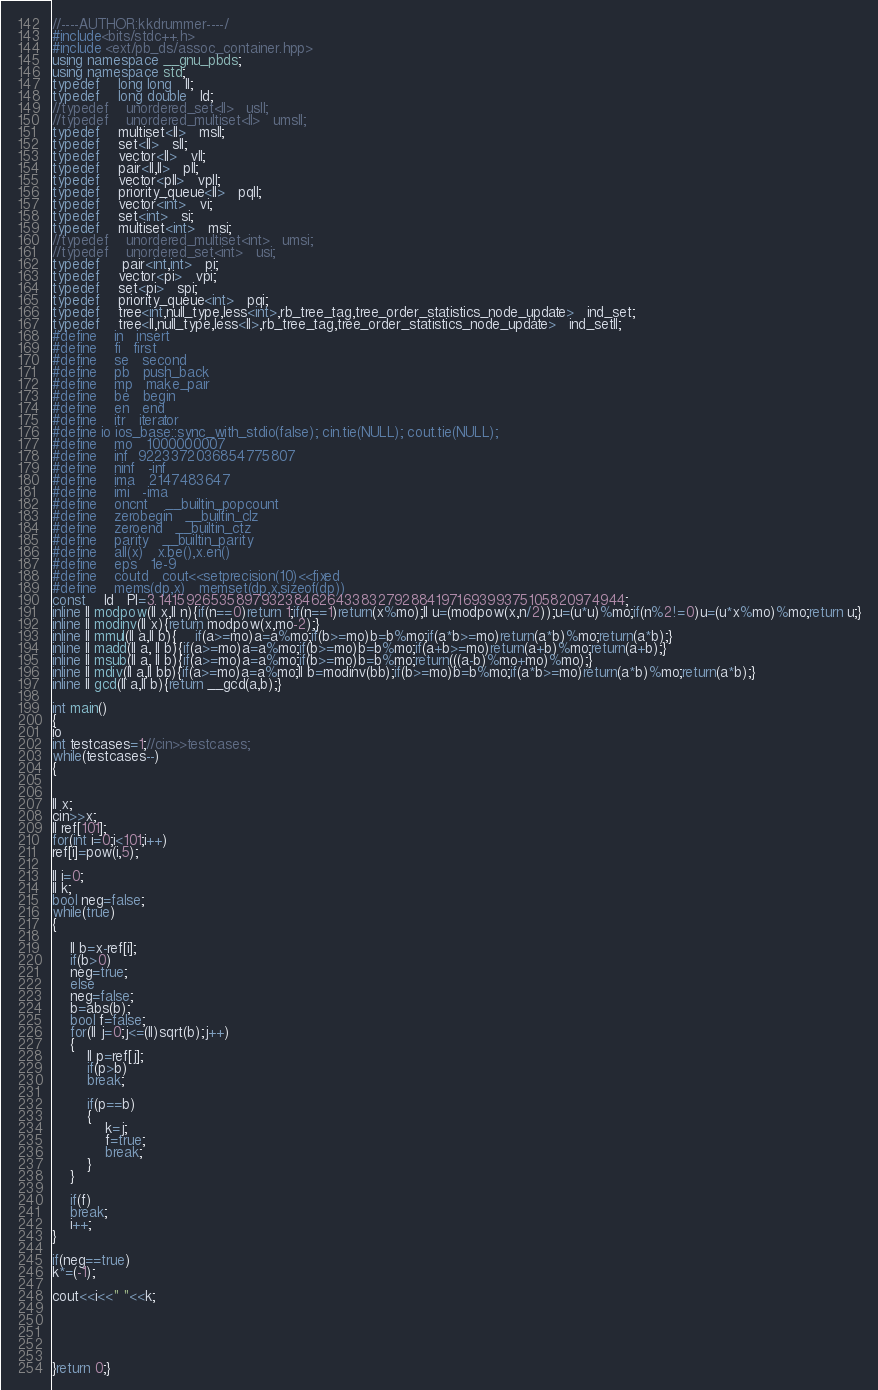Convert code to text. <code><loc_0><loc_0><loc_500><loc_500><_C++_>//----AUTHOR:kkdrummer----/
#include<bits/stdc++.h>
#include <ext/pb_ds/assoc_container.hpp>
using namespace __gnu_pbds;
using namespace std;
typedef    long long   ll;
typedef    long double   ld;
//typedef    unordered_set<ll>   usll;
//typedef    unordered_multiset<ll>   umsll;
typedef    multiset<ll>   msll;
typedef    set<ll>   sll;
typedef    vector<ll>   vll;
typedef    pair<ll,ll>   pll;
typedef    vector<pll>   vpll;
typedef    priority_queue<ll>   pqll;
typedef    vector<int>   vi;
typedef    set<int>   si;
typedef    multiset<int>   msi;
//typedef    unordered_multiset<int>   umsi;
//typedef    unordered_set<int>   usi;
typedef     pair<int,int>   pi;
typedef    vector<pi>   vpi;
typedef    set<pi>   spi;
typedef    priority_queue<int>   pqi;
typedef    tree<int,null_type,less<int>,rb_tree_tag,tree_order_statistics_node_update>   ind_set;
typedef    tree<ll,null_type,less<ll>,rb_tree_tag,tree_order_statistics_node_update>   ind_setll;
#define    in   insert
#define    fi   first
#define    se   second
#define    pb   push_back
#define    mp   make_pair
#define    be   begin
#define    en   end
#define    itr   iterator
#define io ios_base::sync_with_stdio(false); cin.tie(NULL); cout.tie(NULL);
#define    mo   1000000007
#define    inf  9223372036854775807
#define    ninf   -inf
#define    ima   2147483647
#define    imi   -ima
#define    oncnt    __builtin_popcount
#define    zerobegin   __builtin_clz
#define    zeroend   __builtin_ctz
#define    parity   __builtin_parity
#define    all(x)   x.be(),x.en()
#define    eps   1e-9
#define    coutd   cout<<setprecision(10)<<fixed
#define    mems(dp,x)   memset(dp,x,sizeof(dp))
const    ld   PI=3.1415926535897932384626433832792884197169399375105820974944;
inline ll modpow(ll x,ll n){if(n==0)return 1;if(n==1)return(x%mo);ll u=(modpow(x,n/2));u=(u*u)%mo;if(n%2!=0)u=(u*x%mo)%mo;return u;}
inline ll modinv(ll x){return modpow(x,mo-2);}
inline ll mmul(ll a,ll b){    if(a>=mo)a=a%mo;if(b>=mo)b=b%mo;if(a*b>=mo)return(a*b)%mo;return(a*b);}
inline ll madd(ll a, ll b){if(a>=mo)a=a%mo;if(b>=mo)b=b%mo;if(a+b>=mo)return(a+b)%mo;return(a+b);}
inline ll msub(ll a, ll b){if(a>=mo)a=a%mo;if(b>=mo)b=b%mo;return(((a-b)%mo+mo)%mo);}
inline ll mdiv(ll a,ll bb){if(a>=mo)a=a%mo;ll b=modinv(bb);if(b>=mo)b=b%mo;if(a*b>=mo)return(a*b)%mo;return(a*b);}
inline ll gcd(ll a,ll b){return __gcd(a,b);}

int main()
{
io
int testcases=1;//cin>>testcases;
while(testcases--)
{


ll x;
cin>>x;
ll ref[101];
for(int i=0;i<101;i++)
ref[i]=pow(i,5);

ll i=0;
ll k;
bool neg=false;
while(true)
{ 

	ll b=x-ref[i];
	if(b>0)
	neg=true;
	else
	neg=false;
	b=abs(b);
	bool f=false;
	for(ll j=0;j<=(ll)sqrt(b);j++)
	{
		ll p=ref[j];
		if(p>b)
		break;
		
		if(p==b)
		{
			k=j;
			f=true;
			break;
		}
	}
	
	if(f)
	break;
	i++;
}

if(neg==true)
k*=(-1);

cout<<i<<" "<<k;





}return 0;}
</code> 